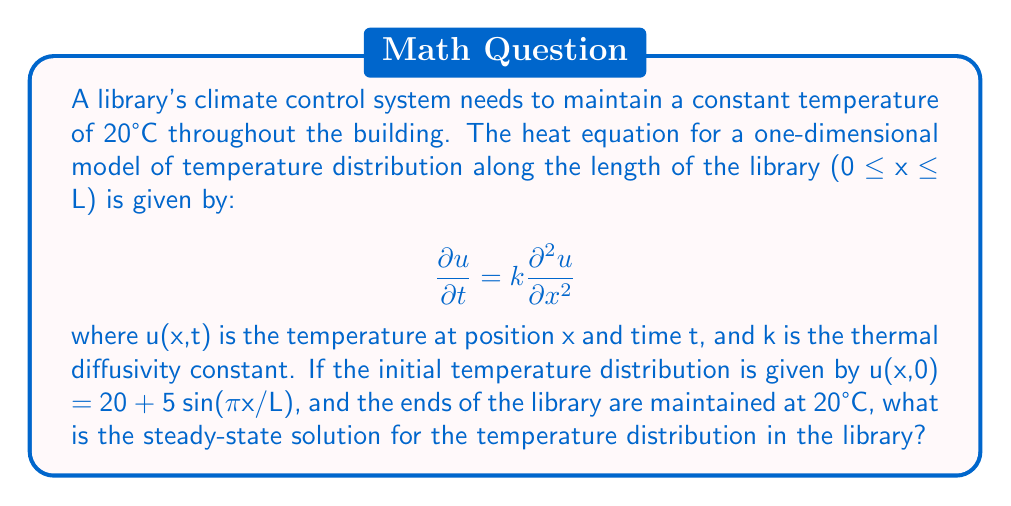Can you answer this question? To solve this problem, we need to follow these steps:

1) First, we recognize that the steady-state solution is independent of time. This means that ∂u/∂t = 0.

2) Applying this to the heat equation, we get:

   $$0 = k\frac{\partial^2 u}{\partial x^2}$$

3) This simplifies to:

   $$\frac{\partial^2 u}{\partial x^2} = 0$$

4) The general solution to this equation is:

   $$u(x) = Ax + B$$

   where A and B are constants we need to determine.

5) Now, we apply the boundary conditions. The ends of the library are maintained at 20°C, so:

   u(0) = 20 and u(L) = 20

6) Applying these conditions to our general solution:

   At x = 0: 20 = A(0) + B, so B = 20
   At x = L: 20 = A(L) + 20

7) From the second condition:

   0 = AL
   A = 0

8) Therefore, our steady-state solution is:

   $$u(x) = 20$$

This makes sense intuitively: in the long run, with constant temperature at the boundaries, the entire library will reach that same temperature.
Answer: u(x) = 20 